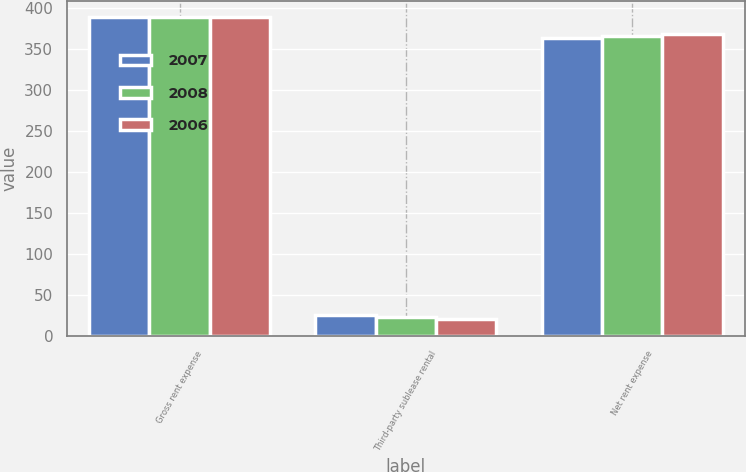Convert chart to OTSL. <chart><loc_0><loc_0><loc_500><loc_500><stacked_bar_chart><ecel><fcel>Gross rent expense<fcel>Third-party sublease rental<fcel>Net rent expense<nl><fcel>2007<fcel>389.4<fcel>24.9<fcel>364.5<nl><fcel>2008<fcel>389.9<fcel>23.5<fcel>366.4<nl><fcel>2006<fcel>389.9<fcel>20.7<fcel>369.2<nl></chart> 